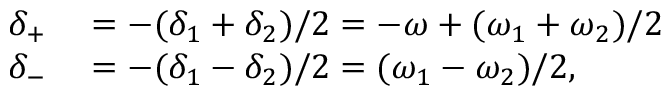Convert formula to latex. <formula><loc_0><loc_0><loc_500><loc_500>\begin{array} { r l } { \delta _ { + } } & = - ( \delta _ { 1 } + \delta _ { 2 } ) / 2 = - \omega + ( \omega _ { 1 } + \omega _ { 2 } ) / 2 } \\ { \delta _ { - } } & = - ( \delta _ { 1 } - \delta _ { 2 } ) / 2 = ( \omega _ { 1 } - \omega _ { 2 } ) / 2 , } \end{array}</formula> 